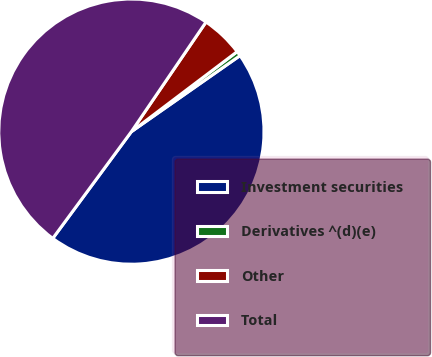Convert chart. <chart><loc_0><loc_0><loc_500><loc_500><pie_chart><fcel>Investment securities<fcel>Derivatives ^(d)(e)<fcel>Other<fcel>Total<nl><fcel>44.82%<fcel>0.59%<fcel>5.18%<fcel>49.41%<nl></chart> 